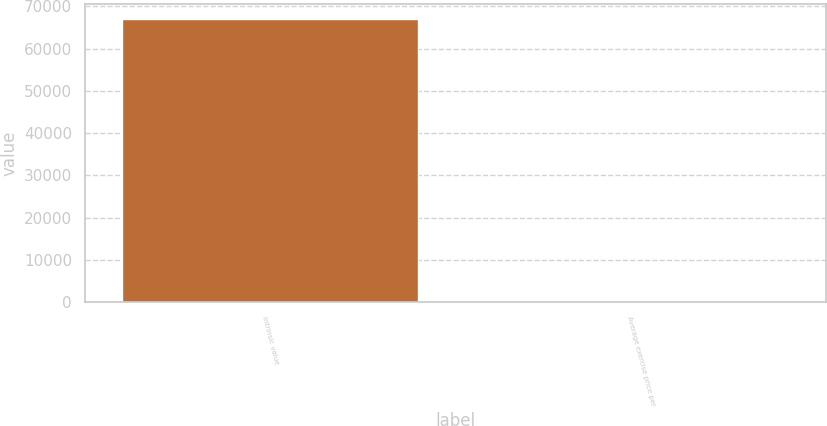Convert chart. <chart><loc_0><loc_0><loc_500><loc_500><bar_chart><fcel>Intrinsic value<fcel>Average exercise price per<nl><fcel>67089<fcel>34.56<nl></chart> 